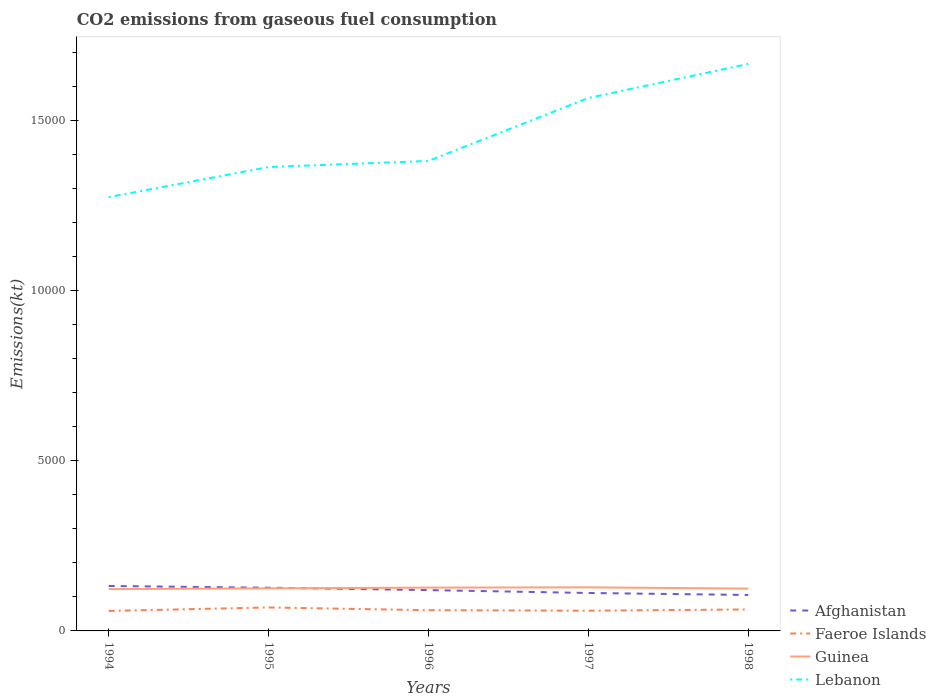How many different coloured lines are there?
Your answer should be very brief. 4. Is the number of lines equal to the number of legend labels?
Keep it short and to the point. Yes. Across all years, what is the maximum amount of CO2 emitted in Guinea?
Provide a short and direct response. 1228.44. In which year was the amount of CO2 emitted in Faeroe Islands maximum?
Ensure brevity in your answer.  1994. What is the total amount of CO2 emitted in Afghanistan in the graph?
Your answer should be compact. 154.01. What is the difference between the highest and the second highest amount of CO2 emitted in Guinea?
Offer a very short reply. 51.34. What is the difference between the highest and the lowest amount of CO2 emitted in Afghanistan?
Your answer should be compact. 3. What is the difference between two consecutive major ticks on the Y-axis?
Keep it short and to the point. 5000. Does the graph contain any zero values?
Provide a succinct answer. No. Does the graph contain grids?
Keep it short and to the point. No. Where does the legend appear in the graph?
Your answer should be very brief. Bottom right. How many legend labels are there?
Provide a short and direct response. 4. How are the legend labels stacked?
Your answer should be compact. Vertical. What is the title of the graph?
Provide a succinct answer. CO2 emissions from gaseous fuel consumption. What is the label or title of the Y-axis?
Your response must be concise. Emissions(kt). What is the Emissions(kt) in Afghanistan in 1994?
Provide a short and direct response. 1320.12. What is the Emissions(kt) in Faeroe Islands in 1994?
Make the answer very short. 586.72. What is the Emissions(kt) in Guinea in 1994?
Ensure brevity in your answer.  1228.44. What is the Emissions(kt) of Lebanon in 1994?
Give a very brief answer. 1.27e+04. What is the Emissions(kt) in Afghanistan in 1995?
Provide a succinct answer. 1268.78. What is the Emissions(kt) of Faeroe Islands in 1995?
Offer a very short reply. 689.4. What is the Emissions(kt) in Guinea in 1995?
Your answer should be compact. 1250.45. What is the Emissions(kt) in Lebanon in 1995?
Provide a succinct answer. 1.36e+04. What is the Emissions(kt) in Afghanistan in 1996?
Your answer should be very brief. 1199.11. What is the Emissions(kt) in Faeroe Islands in 1996?
Ensure brevity in your answer.  608.72. What is the Emissions(kt) in Guinea in 1996?
Offer a terse response. 1272.45. What is the Emissions(kt) of Lebanon in 1996?
Your answer should be very brief. 1.38e+04. What is the Emissions(kt) in Afghanistan in 1997?
Provide a succinct answer. 1114.77. What is the Emissions(kt) of Faeroe Islands in 1997?
Your answer should be very brief. 594.05. What is the Emissions(kt) in Guinea in 1997?
Your response must be concise. 1279.78. What is the Emissions(kt) in Lebanon in 1997?
Provide a succinct answer. 1.57e+04. What is the Emissions(kt) in Afghanistan in 1998?
Offer a very short reply. 1056.1. What is the Emissions(kt) of Faeroe Islands in 1998?
Provide a short and direct response. 630.72. What is the Emissions(kt) of Guinea in 1998?
Offer a very short reply. 1243.11. What is the Emissions(kt) of Lebanon in 1998?
Ensure brevity in your answer.  1.67e+04. Across all years, what is the maximum Emissions(kt) of Afghanistan?
Offer a terse response. 1320.12. Across all years, what is the maximum Emissions(kt) of Faeroe Islands?
Provide a succinct answer. 689.4. Across all years, what is the maximum Emissions(kt) of Guinea?
Offer a very short reply. 1279.78. Across all years, what is the maximum Emissions(kt) in Lebanon?
Keep it short and to the point. 1.67e+04. Across all years, what is the minimum Emissions(kt) of Afghanistan?
Make the answer very short. 1056.1. Across all years, what is the minimum Emissions(kt) of Faeroe Islands?
Ensure brevity in your answer.  586.72. Across all years, what is the minimum Emissions(kt) of Guinea?
Keep it short and to the point. 1228.44. Across all years, what is the minimum Emissions(kt) in Lebanon?
Your answer should be compact. 1.27e+04. What is the total Emissions(kt) in Afghanistan in the graph?
Keep it short and to the point. 5958.88. What is the total Emissions(kt) of Faeroe Islands in the graph?
Provide a succinct answer. 3109.62. What is the total Emissions(kt) in Guinea in the graph?
Keep it short and to the point. 6274.24. What is the total Emissions(kt) of Lebanon in the graph?
Provide a succinct answer. 7.25e+04. What is the difference between the Emissions(kt) in Afghanistan in 1994 and that in 1995?
Keep it short and to the point. 51.34. What is the difference between the Emissions(kt) in Faeroe Islands in 1994 and that in 1995?
Your answer should be compact. -102.68. What is the difference between the Emissions(kt) of Guinea in 1994 and that in 1995?
Provide a short and direct response. -22. What is the difference between the Emissions(kt) in Lebanon in 1994 and that in 1995?
Offer a very short reply. -883.75. What is the difference between the Emissions(kt) of Afghanistan in 1994 and that in 1996?
Your answer should be very brief. 121.01. What is the difference between the Emissions(kt) in Faeroe Islands in 1994 and that in 1996?
Provide a succinct answer. -22. What is the difference between the Emissions(kt) of Guinea in 1994 and that in 1996?
Ensure brevity in your answer.  -44. What is the difference between the Emissions(kt) of Lebanon in 1994 and that in 1996?
Your answer should be very brief. -1063.43. What is the difference between the Emissions(kt) in Afghanistan in 1994 and that in 1997?
Offer a very short reply. 205.35. What is the difference between the Emissions(kt) of Faeroe Islands in 1994 and that in 1997?
Your answer should be very brief. -7.33. What is the difference between the Emissions(kt) of Guinea in 1994 and that in 1997?
Your answer should be very brief. -51.34. What is the difference between the Emissions(kt) of Lebanon in 1994 and that in 1997?
Your answer should be compact. -2911.6. What is the difference between the Emissions(kt) in Afghanistan in 1994 and that in 1998?
Provide a succinct answer. 264.02. What is the difference between the Emissions(kt) in Faeroe Islands in 1994 and that in 1998?
Offer a terse response. -44. What is the difference between the Emissions(kt) in Guinea in 1994 and that in 1998?
Provide a short and direct response. -14.67. What is the difference between the Emissions(kt) in Lebanon in 1994 and that in 1998?
Your response must be concise. -3912.69. What is the difference between the Emissions(kt) of Afghanistan in 1995 and that in 1996?
Provide a short and direct response. 69.67. What is the difference between the Emissions(kt) of Faeroe Islands in 1995 and that in 1996?
Ensure brevity in your answer.  80.67. What is the difference between the Emissions(kt) in Guinea in 1995 and that in 1996?
Give a very brief answer. -22. What is the difference between the Emissions(kt) of Lebanon in 1995 and that in 1996?
Make the answer very short. -179.68. What is the difference between the Emissions(kt) in Afghanistan in 1995 and that in 1997?
Your answer should be compact. 154.01. What is the difference between the Emissions(kt) of Faeroe Islands in 1995 and that in 1997?
Provide a succinct answer. 95.34. What is the difference between the Emissions(kt) of Guinea in 1995 and that in 1997?
Provide a short and direct response. -29.34. What is the difference between the Emissions(kt) of Lebanon in 1995 and that in 1997?
Your response must be concise. -2027.85. What is the difference between the Emissions(kt) of Afghanistan in 1995 and that in 1998?
Make the answer very short. 212.69. What is the difference between the Emissions(kt) of Faeroe Islands in 1995 and that in 1998?
Ensure brevity in your answer.  58.67. What is the difference between the Emissions(kt) in Guinea in 1995 and that in 1998?
Provide a short and direct response. 7.33. What is the difference between the Emissions(kt) in Lebanon in 1995 and that in 1998?
Your response must be concise. -3028.94. What is the difference between the Emissions(kt) of Afghanistan in 1996 and that in 1997?
Your answer should be very brief. 84.34. What is the difference between the Emissions(kt) in Faeroe Islands in 1996 and that in 1997?
Ensure brevity in your answer.  14.67. What is the difference between the Emissions(kt) of Guinea in 1996 and that in 1997?
Offer a terse response. -7.33. What is the difference between the Emissions(kt) of Lebanon in 1996 and that in 1997?
Provide a short and direct response. -1848.17. What is the difference between the Emissions(kt) of Afghanistan in 1996 and that in 1998?
Your response must be concise. 143.01. What is the difference between the Emissions(kt) in Faeroe Islands in 1996 and that in 1998?
Give a very brief answer. -22. What is the difference between the Emissions(kt) in Guinea in 1996 and that in 1998?
Keep it short and to the point. 29.34. What is the difference between the Emissions(kt) in Lebanon in 1996 and that in 1998?
Provide a succinct answer. -2849.26. What is the difference between the Emissions(kt) in Afghanistan in 1997 and that in 1998?
Offer a very short reply. 58.67. What is the difference between the Emissions(kt) of Faeroe Islands in 1997 and that in 1998?
Give a very brief answer. -36.67. What is the difference between the Emissions(kt) in Guinea in 1997 and that in 1998?
Give a very brief answer. 36.67. What is the difference between the Emissions(kt) of Lebanon in 1997 and that in 1998?
Make the answer very short. -1001.09. What is the difference between the Emissions(kt) in Afghanistan in 1994 and the Emissions(kt) in Faeroe Islands in 1995?
Ensure brevity in your answer.  630.72. What is the difference between the Emissions(kt) of Afghanistan in 1994 and the Emissions(kt) of Guinea in 1995?
Your response must be concise. 69.67. What is the difference between the Emissions(kt) of Afghanistan in 1994 and the Emissions(kt) of Lebanon in 1995?
Provide a short and direct response. -1.23e+04. What is the difference between the Emissions(kt) in Faeroe Islands in 1994 and the Emissions(kt) in Guinea in 1995?
Provide a short and direct response. -663.73. What is the difference between the Emissions(kt) of Faeroe Islands in 1994 and the Emissions(kt) of Lebanon in 1995?
Provide a succinct answer. -1.30e+04. What is the difference between the Emissions(kt) of Guinea in 1994 and the Emissions(kt) of Lebanon in 1995?
Offer a terse response. -1.24e+04. What is the difference between the Emissions(kt) in Afghanistan in 1994 and the Emissions(kt) in Faeroe Islands in 1996?
Offer a very short reply. 711.4. What is the difference between the Emissions(kt) of Afghanistan in 1994 and the Emissions(kt) of Guinea in 1996?
Offer a very short reply. 47.67. What is the difference between the Emissions(kt) of Afghanistan in 1994 and the Emissions(kt) of Lebanon in 1996?
Provide a succinct answer. -1.25e+04. What is the difference between the Emissions(kt) in Faeroe Islands in 1994 and the Emissions(kt) in Guinea in 1996?
Offer a terse response. -685.73. What is the difference between the Emissions(kt) in Faeroe Islands in 1994 and the Emissions(kt) in Lebanon in 1996?
Offer a terse response. -1.32e+04. What is the difference between the Emissions(kt) of Guinea in 1994 and the Emissions(kt) of Lebanon in 1996?
Give a very brief answer. -1.26e+04. What is the difference between the Emissions(kt) of Afghanistan in 1994 and the Emissions(kt) of Faeroe Islands in 1997?
Offer a very short reply. 726.07. What is the difference between the Emissions(kt) of Afghanistan in 1994 and the Emissions(kt) of Guinea in 1997?
Keep it short and to the point. 40.34. What is the difference between the Emissions(kt) of Afghanistan in 1994 and the Emissions(kt) of Lebanon in 1997?
Offer a terse response. -1.43e+04. What is the difference between the Emissions(kt) in Faeroe Islands in 1994 and the Emissions(kt) in Guinea in 1997?
Provide a short and direct response. -693.06. What is the difference between the Emissions(kt) of Faeroe Islands in 1994 and the Emissions(kt) of Lebanon in 1997?
Your answer should be very brief. -1.51e+04. What is the difference between the Emissions(kt) of Guinea in 1994 and the Emissions(kt) of Lebanon in 1997?
Your answer should be very brief. -1.44e+04. What is the difference between the Emissions(kt) of Afghanistan in 1994 and the Emissions(kt) of Faeroe Islands in 1998?
Provide a succinct answer. 689.4. What is the difference between the Emissions(kt) of Afghanistan in 1994 and the Emissions(kt) of Guinea in 1998?
Ensure brevity in your answer.  77.01. What is the difference between the Emissions(kt) of Afghanistan in 1994 and the Emissions(kt) of Lebanon in 1998?
Your answer should be compact. -1.53e+04. What is the difference between the Emissions(kt) in Faeroe Islands in 1994 and the Emissions(kt) in Guinea in 1998?
Keep it short and to the point. -656.39. What is the difference between the Emissions(kt) in Faeroe Islands in 1994 and the Emissions(kt) in Lebanon in 1998?
Give a very brief answer. -1.61e+04. What is the difference between the Emissions(kt) in Guinea in 1994 and the Emissions(kt) in Lebanon in 1998?
Keep it short and to the point. -1.54e+04. What is the difference between the Emissions(kt) in Afghanistan in 1995 and the Emissions(kt) in Faeroe Islands in 1996?
Offer a terse response. 660.06. What is the difference between the Emissions(kt) of Afghanistan in 1995 and the Emissions(kt) of Guinea in 1996?
Your answer should be very brief. -3.67. What is the difference between the Emissions(kt) in Afghanistan in 1995 and the Emissions(kt) in Lebanon in 1996?
Your answer should be very brief. -1.25e+04. What is the difference between the Emissions(kt) of Faeroe Islands in 1995 and the Emissions(kt) of Guinea in 1996?
Provide a short and direct response. -583.05. What is the difference between the Emissions(kt) in Faeroe Islands in 1995 and the Emissions(kt) in Lebanon in 1996?
Provide a short and direct response. -1.31e+04. What is the difference between the Emissions(kt) of Guinea in 1995 and the Emissions(kt) of Lebanon in 1996?
Provide a short and direct response. -1.26e+04. What is the difference between the Emissions(kt) of Afghanistan in 1995 and the Emissions(kt) of Faeroe Islands in 1997?
Your answer should be compact. 674.73. What is the difference between the Emissions(kt) of Afghanistan in 1995 and the Emissions(kt) of Guinea in 1997?
Offer a very short reply. -11. What is the difference between the Emissions(kt) of Afghanistan in 1995 and the Emissions(kt) of Lebanon in 1997?
Offer a terse response. -1.44e+04. What is the difference between the Emissions(kt) of Faeroe Islands in 1995 and the Emissions(kt) of Guinea in 1997?
Provide a succinct answer. -590.39. What is the difference between the Emissions(kt) of Faeroe Islands in 1995 and the Emissions(kt) of Lebanon in 1997?
Provide a succinct answer. -1.50e+04. What is the difference between the Emissions(kt) in Guinea in 1995 and the Emissions(kt) in Lebanon in 1997?
Provide a short and direct response. -1.44e+04. What is the difference between the Emissions(kt) of Afghanistan in 1995 and the Emissions(kt) of Faeroe Islands in 1998?
Offer a very short reply. 638.06. What is the difference between the Emissions(kt) in Afghanistan in 1995 and the Emissions(kt) in Guinea in 1998?
Provide a succinct answer. 25.67. What is the difference between the Emissions(kt) in Afghanistan in 1995 and the Emissions(kt) in Lebanon in 1998?
Make the answer very short. -1.54e+04. What is the difference between the Emissions(kt) of Faeroe Islands in 1995 and the Emissions(kt) of Guinea in 1998?
Provide a succinct answer. -553.72. What is the difference between the Emissions(kt) of Faeroe Islands in 1995 and the Emissions(kt) of Lebanon in 1998?
Make the answer very short. -1.60e+04. What is the difference between the Emissions(kt) of Guinea in 1995 and the Emissions(kt) of Lebanon in 1998?
Offer a very short reply. -1.54e+04. What is the difference between the Emissions(kt) in Afghanistan in 1996 and the Emissions(kt) in Faeroe Islands in 1997?
Your answer should be very brief. 605.05. What is the difference between the Emissions(kt) of Afghanistan in 1996 and the Emissions(kt) of Guinea in 1997?
Your answer should be compact. -80.67. What is the difference between the Emissions(kt) of Afghanistan in 1996 and the Emissions(kt) of Lebanon in 1997?
Ensure brevity in your answer.  -1.45e+04. What is the difference between the Emissions(kt) in Faeroe Islands in 1996 and the Emissions(kt) in Guinea in 1997?
Keep it short and to the point. -671.06. What is the difference between the Emissions(kt) in Faeroe Islands in 1996 and the Emissions(kt) in Lebanon in 1997?
Make the answer very short. -1.50e+04. What is the difference between the Emissions(kt) in Guinea in 1996 and the Emissions(kt) in Lebanon in 1997?
Your response must be concise. -1.44e+04. What is the difference between the Emissions(kt) in Afghanistan in 1996 and the Emissions(kt) in Faeroe Islands in 1998?
Ensure brevity in your answer.  568.38. What is the difference between the Emissions(kt) of Afghanistan in 1996 and the Emissions(kt) of Guinea in 1998?
Your answer should be very brief. -44. What is the difference between the Emissions(kt) of Afghanistan in 1996 and the Emissions(kt) of Lebanon in 1998?
Your answer should be very brief. -1.55e+04. What is the difference between the Emissions(kt) in Faeroe Islands in 1996 and the Emissions(kt) in Guinea in 1998?
Your response must be concise. -634.39. What is the difference between the Emissions(kt) in Faeroe Islands in 1996 and the Emissions(kt) in Lebanon in 1998?
Your answer should be very brief. -1.60e+04. What is the difference between the Emissions(kt) in Guinea in 1996 and the Emissions(kt) in Lebanon in 1998?
Provide a short and direct response. -1.54e+04. What is the difference between the Emissions(kt) in Afghanistan in 1997 and the Emissions(kt) in Faeroe Islands in 1998?
Ensure brevity in your answer.  484.04. What is the difference between the Emissions(kt) in Afghanistan in 1997 and the Emissions(kt) in Guinea in 1998?
Keep it short and to the point. -128.34. What is the difference between the Emissions(kt) in Afghanistan in 1997 and the Emissions(kt) in Lebanon in 1998?
Ensure brevity in your answer.  -1.55e+04. What is the difference between the Emissions(kt) in Faeroe Islands in 1997 and the Emissions(kt) in Guinea in 1998?
Give a very brief answer. -649.06. What is the difference between the Emissions(kt) in Faeroe Islands in 1997 and the Emissions(kt) in Lebanon in 1998?
Offer a very short reply. -1.61e+04. What is the difference between the Emissions(kt) of Guinea in 1997 and the Emissions(kt) of Lebanon in 1998?
Offer a terse response. -1.54e+04. What is the average Emissions(kt) of Afghanistan per year?
Offer a terse response. 1191.78. What is the average Emissions(kt) of Faeroe Islands per year?
Give a very brief answer. 621.92. What is the average Emissions(kt) in Guinea per year?
Your response must be concise. 1254.85. What is the average Emissions(kt) in Lebanon per year?
Give a very brief answer. 1.45e+04. In the year 1994, what is the difference between the Emissions(kt) in Afghanistan and Emissions(kt) in Faeroe Islands?
Give a very brief answer. 733.4. In the year 1994, what is the difference between the Emissions(kt) in Afghanistan and Emissions(kt) in Guinea?
Offer a terse response. 91.67. In the year 1994, what is the difference between the Emissions(kt) in Afghanistan and Emissions(kt) in Lebanon?
Provide a succinct answer. -1.14e+04. In the year 1994, what is the difference between the Emissions(kt) in Faeroe Islands and Emissions(kt) in Guinea?
Offer a very short reply. -641.73. In the year 1994, what is the difference between the Emissions(kt) of Faeroe Islands and Emissions(kt) of Lebanon?
Keep it short and to the point. -1.22e+04. In the year 1994, what is the difference between the Emissions(kt) in Guinea and Emissions(kt) in Lebanon?
Offer a terse response. -1.15e+04. In the year 1995, what is the difference between the Emissions(kt) in Afghanistan and Emissions(kt) in Faeroe Islands?
Your answer should be compact. 579.39. In the year 1995, what is the difference between the Emissions(kt) of Afghanistan and Emissions(kt) of Guinea?
Provide a succinct answer. 18.34. In the year 1995, what is the difference between the Emissions(kt) of Afghanistan and Emissions(kt) of Lebanon?
Offer a very short reply. -1.24e+04. In the year 1995, what is the difference between the Emissions(kt) in Faeroe Islands and Emissions(kt) in Guinea?
Keep it short and to the point. -561.05. In the year 1995, what is the difference between the Emissions(kt) of Faeroe Islands and Emissions(kt) of Lebanon?
Provide a short and direct response. -1.29e+04. In the year 1995, what is the difference between the Emissions(kt) in Guinea and Emissions(kt) in Lebanon?
Offer a very short reply. -1.24e+04. In the year 1996, what is the difference between the Emissions(kt) of Afghanistan and Emissions(kt) of Faeroe Islands?
Your answer should be compact. 590.39. In the year 1996, what is the difference between the Emissions(kt) in Afghanistan and Emissions(kt) in Guinea?
Your answer should be compact. -73.34. In the year 1996, what is the difference between the Emissions(kt) of Afghanistan and Emissions(kt) of Lebanon?
Make the answer very short. -1.26e+04. In the year 1996, what is the difference between the Emissions(kt) of Faeroe Islands and Emissions(kt) of Guinea?
Make the answer very short. -663.73. In the year 1996, what is the difference between the Emissions(kt) of Faeroe Islands and Emissions(kt) of Lebanon?
Provide a short and direct response. -1.32e+04. In the year 1996, what is the difference between the Emissions(kt) of Guinea and Emissions(kt) of Lebanon?
Keep it short and to the point. -1.25e+04. In the year 1997, what is the difference between the Emissions(kt) in Afghanistan and Emissions(kt) in Faeroe Islands?
Your response must be concise. 520.71. In the year 1997, what is the difference between the Emissions(kt) of Afghanistan and Emissions(kt) of Guinea?
Offer a very short reply. -165.01. In the year 1997, what is the difference between the Emissions(kt) in Afghanistan and Emissions(kt) in Lebanon?
Your answer should be very brief. -1.45e+04. In the year 1997, what is the difference between the Emissions(kt) of Faeroe Islands and Emissions(kt) of Guinea?
Offer a terse response. -685.73. In the year 1997, what is the difference between the Emissions(kt) in Faeroe Islands and Emissions(kt) in Lebanon?
Provide a short and direct response. -1.51e+04. In the year 1997, what is the difference between the Emissions(kt) of Guinea and Emissions(kt) of Lebanon?
Ensure brevity in your answer.  -1.44e+04. In the year 1998, what is the difference between the Emissions(kt) in Afghanistan and Emissions(kt) in Faeroe Islands?
Offer a terse response. 425.37. In the year 1998, what is the difference between the Emissions(kt) in Afghanistan and Emissions(kt) in Guinea?
Offer a terse response. -187.02. In the year 1998, what is the difference between the Emissions(kt) of Afghanistan and Emissions(kt) of Lebanon?
Ensure brevity in your answer.  -1.56e+04. In the year 1998, what is the difference between the Emissions(kt) of Faeroe Islands and Emissions(kt) of Guinea?
Provide a succinct answer. -612.39. In the year 1998, what is the difference between the Emissions(kt) in Faeroe Islands and Emissions(kt) in Lebanon?
Keep it short and to the point. -1.60e+04. In the year 1998, what is the difference between the Emissions(kt) of Guinea and Emissions(kt) of Lebanon?
Offer a very short reply. -1.54e+04. What is the ratio of the Emissions(kt) in Afghanistan in 1994 to that in 1995?
Ensure brevity in your answer.  1.04. What is the ratio of the Emissions(kt) in Faeroe Islands in 1994 to that in 1995?
Your response must be concise. 0.85. What is the ratio of the Emissions(kt) of Guinea in 1994 to that in 1995?
Offer a terse response. 0.98. What is the ratio of the Emissions(kt) in Lebanon in 1994 to that in 1995?
Provide a short and direct response. 0.94. What is the ratio of the Emissions(kt) of Afghanistan in 1994 to that in 1996?
Your answer should be very brief. 1.1. What is the ratio of the Emissions(kt) in Faeroe Islands in 1994 to that in 1996?
Ensure brevity in your answer.  0.96. What is the ratio of the Emissions(kt) in Guinea in 1994 to that in 1996?
Make the answer very short. 0.97. What is the ratio of the Emissions(kt) of Lebanon in 1994 to that in 1996?
Provide a succinct answer. 0.92. What is the ratio of the Emissions(kt) of Afghanistan in 1994 to that in 1997?
Keep it short and to the point. 1.18. What is the ratio of the Emissions(kt) in Guinea in 1994 to that in 1997?
Offer a very short reply. 0.96. What is the ratio of the Emissions(kt) in Lebanon in 1994 to that in 1997?
Offer a terse response. 0.81. What is the ratio of the Emissions(kt) of Faeroe Islands in 1994 to that in 1998?
Offer a terse response. 0.93. What is the ratio of the Emissions(kt) in Lebanon in 1994 to that in 1998?
Your response must be concise. 0.77. What is the ratio of the Emissions(kt) in Afghanistan in 1995 to that in 1996?
Ensure brevity in your answer.  1.06. What is the ratio of the Emissions(kt) of Faeroe Islands in 1995 to that in 1996?
Offer a terse response. 1.13. What is the ratio of the Emissions(kt) in Guinea in 1995 to that in 1996?
Provide a succinct answer. 0.98. What is the ratio of the Emissions(kt) of Lebanon in 1995 to that in 1996?
Offer a terse response. 0.99. What is the ratio of the Emissions(kt) in Afghanistan in 1995 to that in 1997?
Your response must be concise. 1.14. What is the ratio of the Emissions(kt) in Faeroe Islands in 1995 to that in 1997?
Make the answer very short. 1.16. What is the ratio of the Emissions(kt) in Guinea in 1995 to that in 1997?
Offer a very short reply. 0.98. What is the ratio of the Emissions(kt) in Lebanon in 1995 to that in 1997?
Ensure brevity in your answer.  0.87. What is the ratio of the Emissions(kt) of Afghanistan in 1995 to that in 1998?
Keep it short and to the point. 1.2. What is the ratio of the Emissions(kt) of Faeroe Islands in 1995 to that in 1998?
Make the answer very short. 1.09. What is the ratio of the Emissions(kt) in Guinea in 1995 to that in 1998?
Ensure brevity in your answer.  1.01. What is the ratio of the Emissions(kt) of Lebanon in 1995 to that in 1998?
Ensure brevity in your answer.  0.82. What is the ratio of the Emissions(kt) in Afghanistan in 1996 to that in 1997?
Ensure brevity in your answer.  1.08. What is the ratio of the Emissions(kt) in Faeroe Islands in 1996 to that in 1997?
Provide a succinct answer. 1.02. What is the ratio of the Emissions(kt) of Guinea in 1996 to that in 1997?
Offer a terse response. 0.99. What is the ratio of the Emissions(kt) of Lebanon in 1996 to that in 1997?
Provide a succinct answer. 0.88. What is the ratio of the Emissions(kt) of Afghanistan in 1996 to that in 1998?
Provide a short and direct response. 1.14. What is the ratio of the Emissions(kt) in Faeroe Islands in 1996 to that in 1998?
Offer a terse response. 0.97. What is the ratio of the Emissions(kt) in Guinea in 1996 to that in 1998?
Keep it short and to the point. 1.02. What is the ratio of the Emissions(kt) of Lebanon in 1996 to that in 1998?
Give a very brief answer. 0.83. What is the ratio of the Emissions(kt) in Afghanistan in 1997 to that in 1998?
Offer a terse response. 1.06. What is the ratio of the Emissions(kt) in Faeroe Islands in 1997 to that in 1998?
Provide a short and direct response. 0.94. What is the ratio of the Emissions(kt) in Guinea in 1997 to that in 1998?
Provide a short and direct response. 1.03. What is the ratio of the Emissions(kt) in Lebanon in 1997 to that in 1998?
Keep it short and to the point. 0.94. What is the difference between the highest and the second highest Emissions(kt) in Afghanistan?
Provide a short and direct response. 51.34. What is the difference between the highest and the second highest Emissions(kt) of Faeroe Islands?
Offer a very short reply. 58.67. What is the difference between the highest and the second highest Emissions(kt) in Guinea?
Offer a very short reply. 7.33. What is the difference between the highest and the second highest Emissions(kt) in Lebanon?
Make the answer very short. 1001.09. What is the difference between the highest and the lowest Emissions(kt) of Afghanistan?
Provide a short and direct response. 264.02. What is the difference between the highest and the lowest Emissions(kt) in Faeroe Islands?
Ensure brevity in your answer.  102.68. What is the difference between the highest and the lowest Emissions(kt) of Guinea?
Offer a terse response. 51.34. What is the difference between the highest and the lowest Emissions(kt) of Lebanon?
Make the answer very short. 3912.69. 